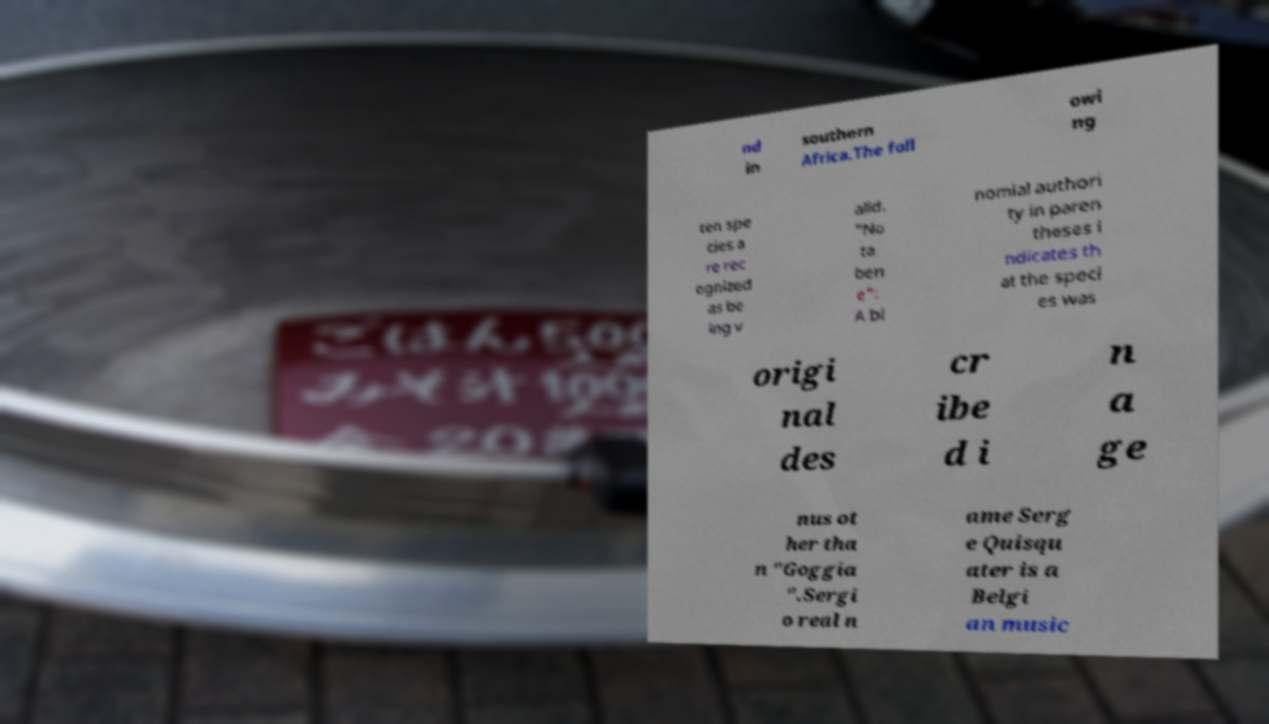Please identify and transcribe the text found in this image. nd in southern Africa.The foll owi ng ten spe cies a re rec ognized as be ing v alid. "No ta ben e": A bi nomial authori ty in paren theses i ndicates th at the speci es was origi nal des cr ibe d i n a ge nus ot her tha n "Goggia ".Sergi o real n ame Serg e Quisqu ater is a Belgi an music 